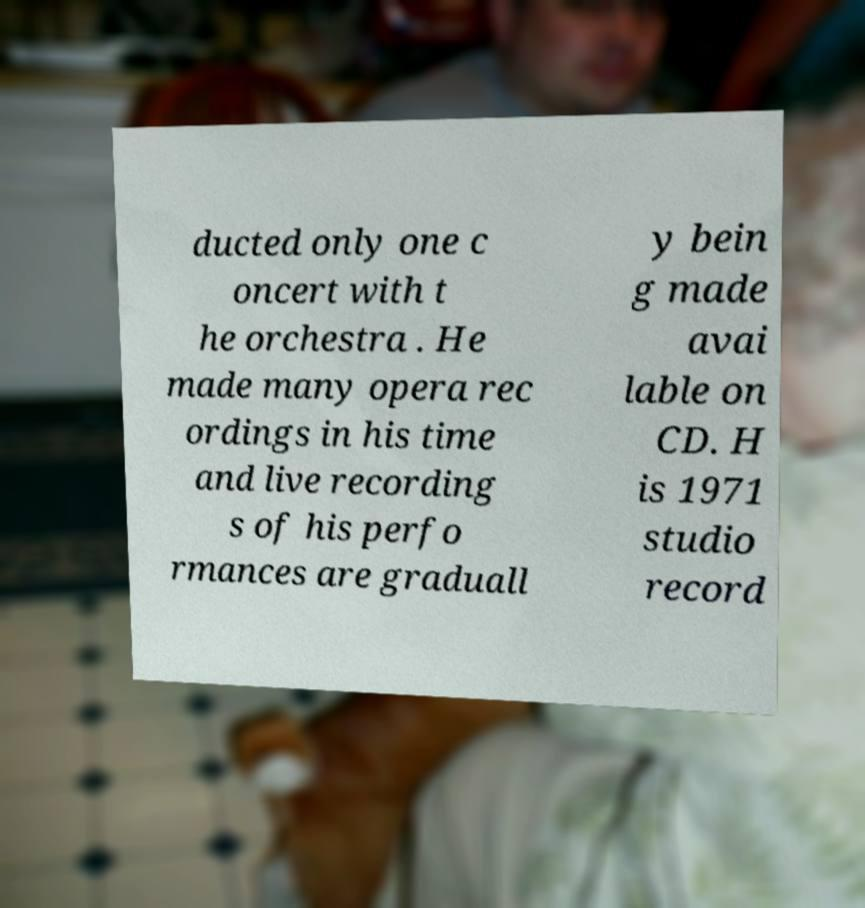Could you assist in decoding the text presented in this image and type it out clearly? ducted only one c oncert with t he orchestra . He made many opera rec ordings in his time and live recording s of his perfo rmances are graduall y bein g made avai lable on CD. H is 1971 studio record 